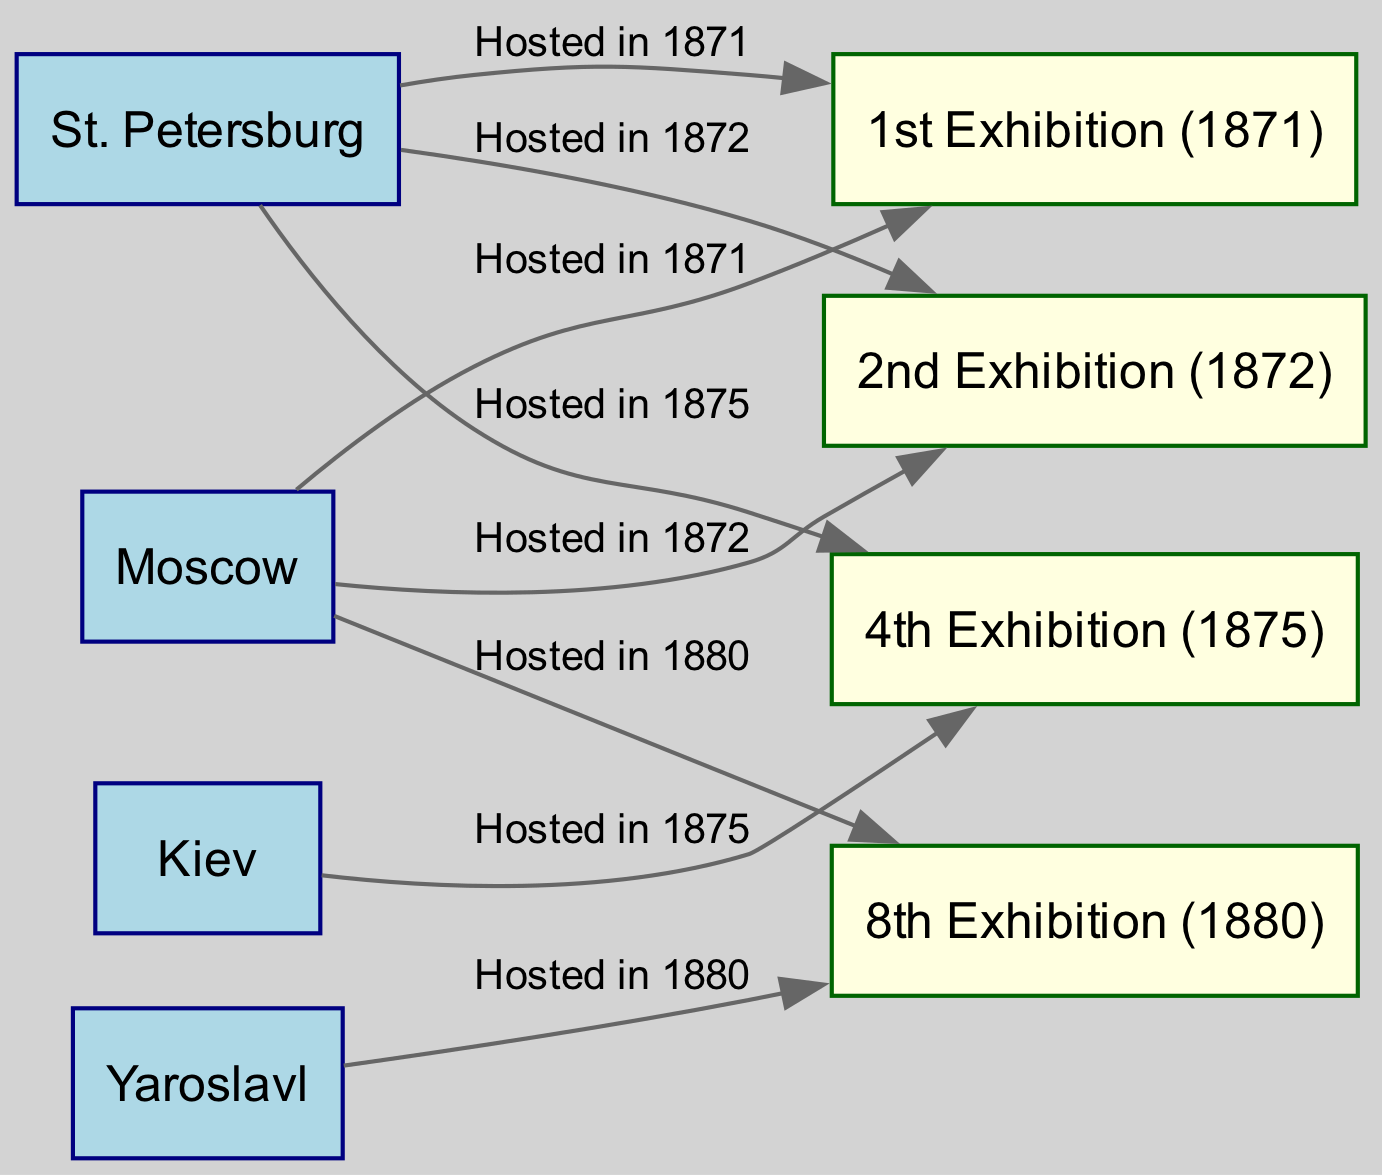What locations hosted the 1st Exhibition? According to the diagram, both St. Petersburg and Moscow are indicated as hosting the 1st Exhibition in 1871. The edges connecting these nodes to the exhibition node clearly state that they hosted this event.
Answer: St. Petersburg, Moscow How many exhibitions were hosted in St. Petersburg? The diagram shows three edges connecting St. Petersburg to the exhibition nodes (1st, 2nd, and 4th Exhibitions), indicating that a total of three exhibitions were hosted in this location.
Answer: 3 Which exhibition was hosted in Kiev? The diagram reveals that the edge from Kiev to the exhibition node (4th Exhibition) highlights that this particular exhibition was hosted there in 1875.
Answer: 4th Exhibition What is the only exhibition hosted in Yaroslavl? The diagram displays a single edge leading from Yaroslavl to the exhibition node (8th Exhibition), meaning this is the only exhibition that was held in that location.
Answer: 8th Exhibition Which two cities hosted the 8th Exhibition? The diagram evidences that both Moscow and Yaroslavl hosted the 8th Exhibition in 1880, as indicated by the edges from both location nodes to the exhibition node.
Answer: Moscow, Yaroslavl How many unique locations are represented in the diagram? The diagram features four unique locations: St. Petersburg, Moscow, Kiev, and Yaroslavl. These are the nodes labeled as locations, and counting them provides the total.
Answer: 4 How many exhibitions were hosted in 1872? From the diagram, it is clear there are two edges pointing to exhibitions hosted in 1872 (1st and 2nd Exhibitions), showing that both of these were held during that year.
Answer: 2 What is the relationship between St. Petersburg and the 2nd Exhibition? The diagram illustrates a direct edge from St. Petersburg to the 2nd Exhibition, explicitly stating that it was hosted there in 1872, indicating a hosting relationship.
Answer: Hosted in 1872 